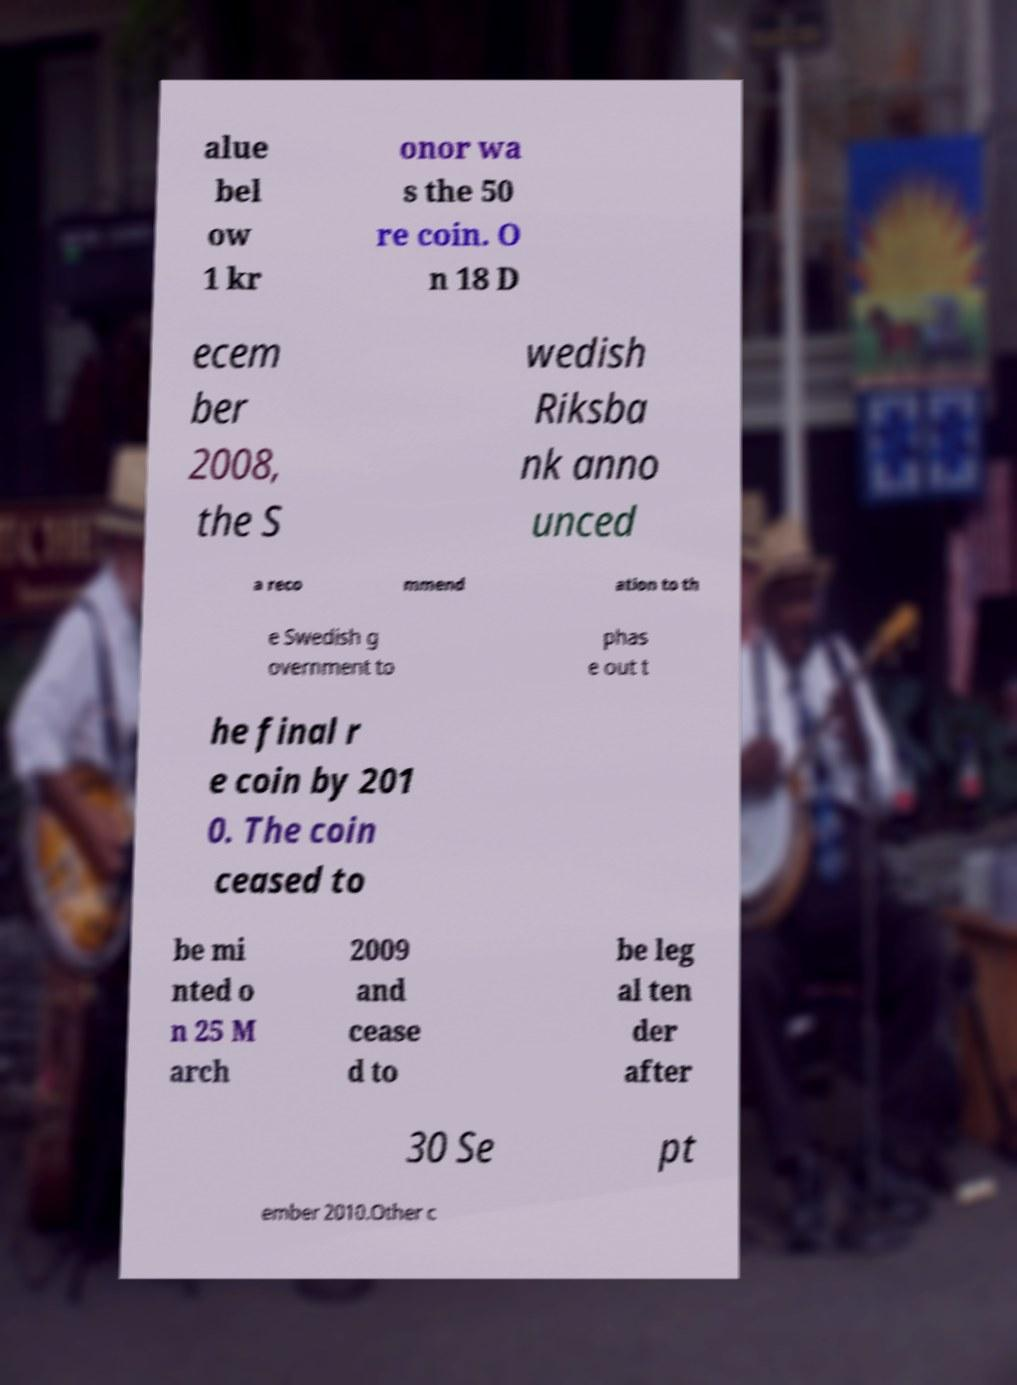Please identify and transcribe the text found in this image. alue bel ow 1 kr onor wa s the 50 re coin. O n 18 D ecem ber 2008, the S wedish Riksba nk anno unced a reco mmend ation to th e Swedish g overnment to phas e out t he final r e coin by 201 0. The coin ceased to be mi nted o n 25 M arch 2009 and cease d to be leg al ten der after 30 Se pt ember 2010.Other c 